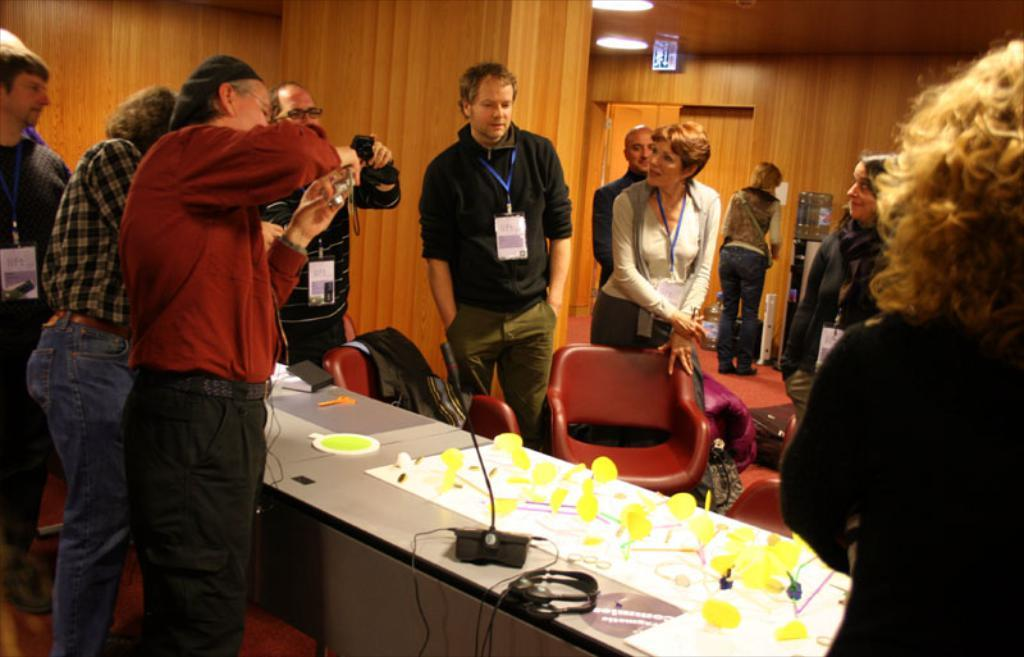What is happening in the image? There are many people standing in the image. What are the people holding in their hands? The people are holding cameras in their hands. What can be seen in the background of the image? There is a wooden wall in the background of the image. How many snails can be seen crawling on the wooden wall in the image? There are no snails visible in the image; the wooden wall is the only element mentioned in the background. 